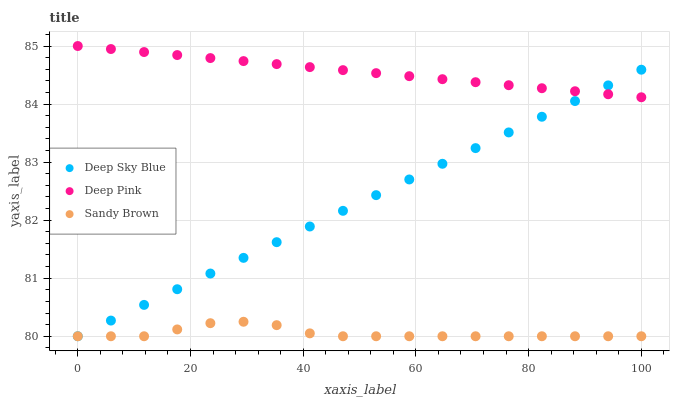Does Sandy Brown have the minimum area under the curve?
Answer yes or no. Yes. Does Deep Pink have the maximum area under the curve?
Answer yes or no. Yes. Does Deep Sky Blue have the minimum area under the curve?
Answer yes or no. No. Does Deep Sky Blue have the maximum area under the curve?
Answer yes or no. No. Is Deep Pink the smoothest?
Answer yes or no. Yes. Is Sandy Brown the roughest?
Answer yes or no. Yes. Is Deep Sky Blue the smoothest?
Answer yes or no. No. Is Deep Sky Blue the roughest?
Answer yes or no. No. Does Sandy Brown have the lowest value?
Answer yes or no. Yes. Does Deep Pink have the highest value?
Answer yes or no. Yes. Does Deep Sky Blue have the highest value?
Answer yes or no. No. Is Sandy Brown less than Deep Pink?
Answer yes or no. Yes. Is Deep Pink greater than Sandy Brown?
Answer yes or no. Yes. Does Sandy Brown intersect Deep Sky Blue?
Answer yes or no. Yes. Is Sandy Brown less than Deep Sky Blue?
Answer yes or no. No. Is Sandy Brown greater than Deep Sky Blue?
Answer yes or no. No. Does Sandy Brown intersect Deep Pink?
Answer yes or no. No. 